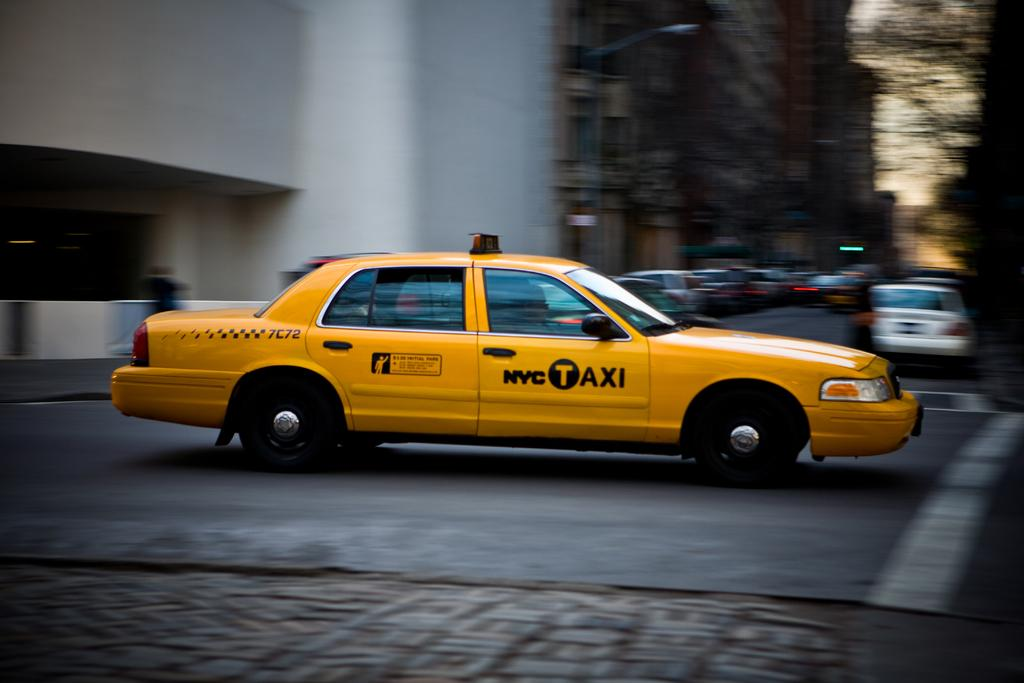<image>
Describe the image concisely. A yellow NYC taxi drives down the street, 